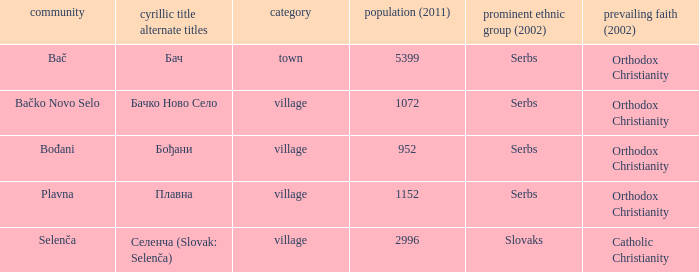How to you write  плавна with the latin alphabet? Plavna. 